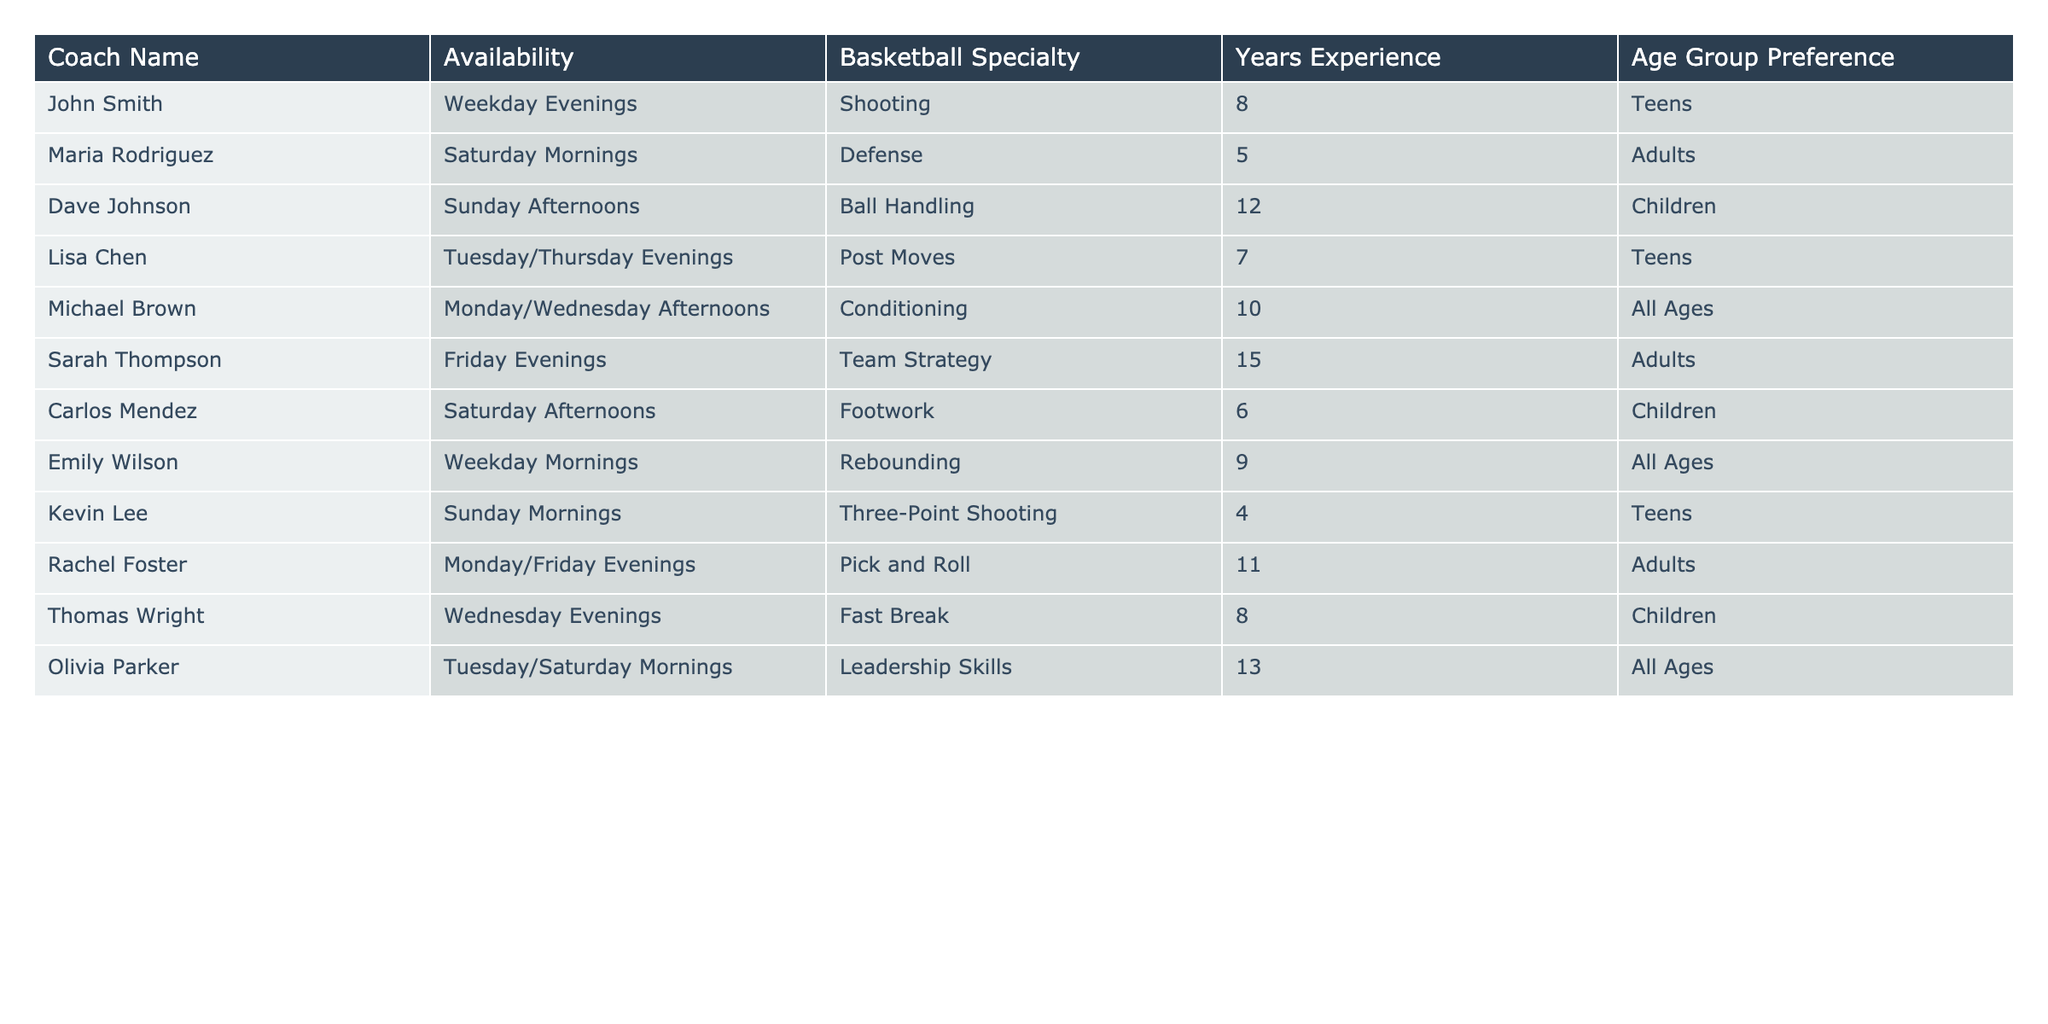What is the availability of Sarah Thompson? By looking at the "Availability" column in the table, we find Sarah Thompson listed under "Friday Evenings."
Answer: Friday Evenings Which coach specializes in ball handling? In the "Basketball Specialty" column, we can see that Dave Johnson is the coach listed for "Ball Handling."
Answer: Dave Johnson How many coaches are available on weekends? By checking the "Availability" column, we find that Maria Rodriguez, Dave Johnson, Carlos Mendez, and Kevin Lee are all available on weekends (Saturday and Sunday), totaling 4 coaches.
Answer: 4 Is there a coach with a specialty in post moves? The "Basketball Specialty" column shows that Lisa Chen is the coach who specializes in "Post Moves." Therefore, the answer is yes.
Answer: Yes What is the average years of experience for all the coaches? Adding the years of experience (8 + 5 + 12 + 7 + 10 + 15 + 6 + 9 + 4 + 11 + 8 + 13) gives 93. There are 12 coaches, so the average is 93/12 = 7.75.
Answer: 7.75 Which age group preference is most common among the coaches? Reviewing the "Age Group Preference" column, we see "All Ages" (Michael Brown, Emily Wilson, and Olivia Parker) is mentioned 3 times, making it more common than the others.
Answer: All Ages Who are the coaches available on weekday evenings? Looking at the "Availability" column, John Smith, Lisa Chen, and Rachel Foster are available on weekday evenings.
Answer: John Smith, Lisa Chen, Rachel Foster Are there any coaches who prefer to work with children? In the "Age Group Preference" column, we find that Dave Johnson, Carlos Mendez, and Thomas Wright all prefer to work with children, so yes, there are coaches for this age group.
Answer: Yes Which coach has the most years of experience and what is their specialty? From the "Years Experience" column, Sarah Thompson has the most at 15 years, and her specialty is "Team Strategy."
Answer: Sarah Thompson, Team Strategy How many coaches are available on weekday mornings? In the "Availability" column, only Emily Wilson is available on weekday mornings, making it 1 coach.
Answer: 1 